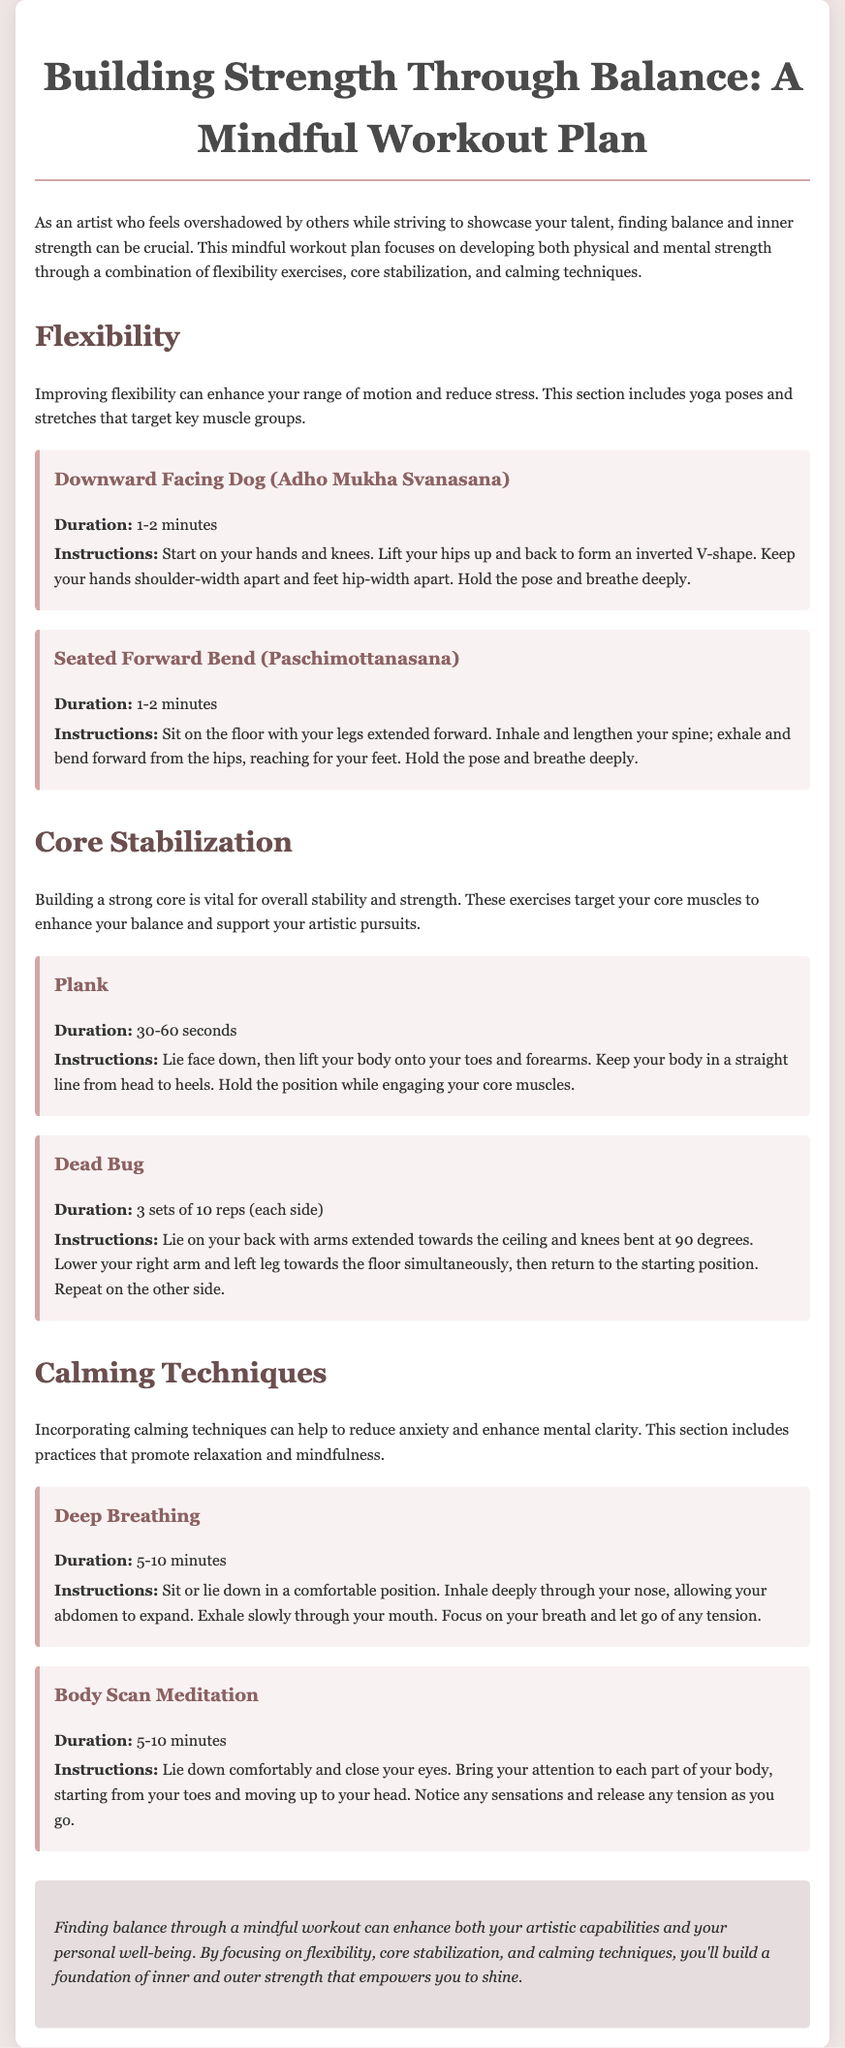what is the main focus of the workout plan? The workout plan focuses on developing both physical and mental strength through a combination of flexibility exercises, core stabilization, and calming techniques.
Answer: physical and mental strength how long should you hold the Downward Facing Dog pose? The duration for the Downward Facing Dog pose is specified in the document, which is 1-2 minutes.
Answer: 1-2 minutes what exercise is performed for core stabilization? The document lists several exercises, one of which is the Plank.
Answer: Plank how many sets of Dead Bug should be done? The instructions for the Dead Bug indicate that it should be performed for 3 sets of 10 reps (each side).
Answer: 3 sets of 10 reps what is one calming technique mentioned in the plan? The workout plan includes several calming techniques, one being Deep Breathing.
Answer: Deep Breathing what position should you start in for the Seated Forward Bend? The instructions for Seated Forward Bend specify that you should sit on the floor with your legs extended forward.
Answer: seated on the floor with legs extended forward what is the duration for the Body Scan Meditation? The duration for the Body Scan Meditation is specified in the document, which is 5-10 minutes.
Answer: 5-10 minutes how does the workout plan help artists? The document states that it enhances both artistic capabilities and personal well-being.
Answer: artistic capabilities and personal well-being 